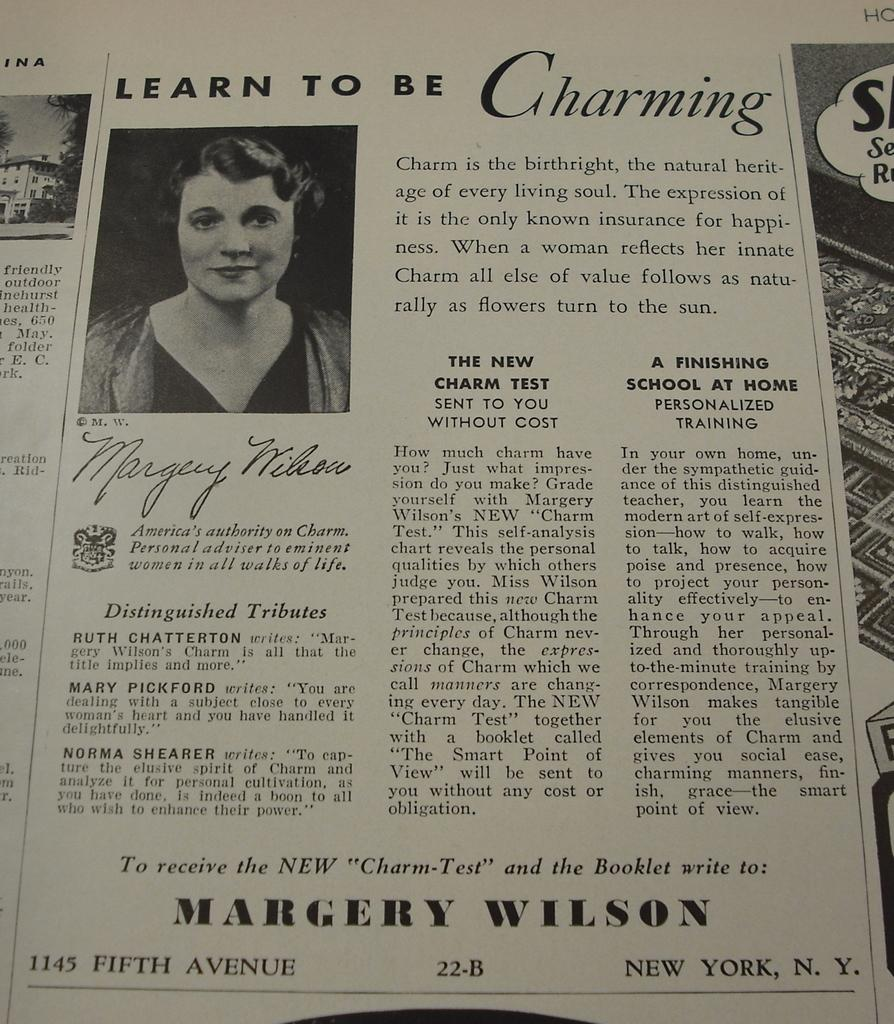What is present in the image that has both images and text? There is a paper in the image that has images and text on it. What type of soup is being served on the paper in the image? There is no soup present on the paper in the image; it only has images and text. What kind of spark can be seen coming from the text on the paper? There is no spark present on the paper in the image; it only has images and text. 